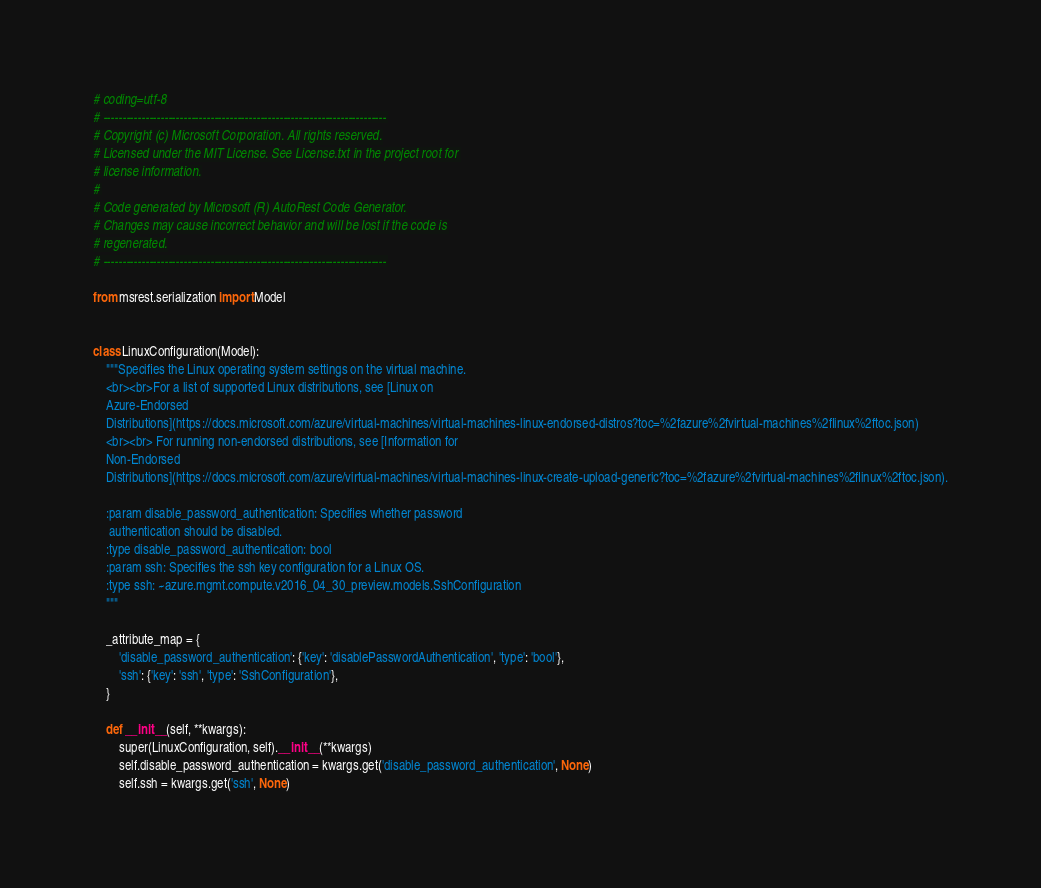<code> <loc_0><loc_0><loc_500><loc_500><_Python_># coding=utf-8
# --------------------------------------------------------------------------
# Copyright (c) Microsoft Corporation. All rights reserved.
# Licensed under the MIT License. See License.txt in the project root for
# license information.
#
# Code generated by Microsoft (R) AutoRest Code Generator.
# Changes may cause incorrect behavior and will be lost if the code is
# regenerated.
# --------------------------------------------------------------------------

from msrest.serialization import Model


class LinuxConfiguration(Model):
    """Specifies the Linux operating system settings on the virtual machine.
    <br><br>For a list of supported Linux distributions, see [Linux on
    Azure-Endorsed
    Distributions](https://docs.microsoft.com/azure/virtual-machines/virtual-machines-linux-endorsed-distros?toc=%2fazure%2fvirtual-machines%2flinux%2ftoc.json)
    <br><br> For running non-endorsed distributions, see [Information for
    Non-Endorsed
    Distributions](https://docs.microsoft.com/azure/virtual-machines/virtual-machines-linux-create-upload-generic?toc=%2fazure%2fvirtual-machines%2flinux%2ftoc.json).

    :param disable_password_authentication: Specifies whether password
     authentication should be disabled.
    :type disable_password_authentication: bool
    :param ssh: Specifies the ssh key configuration for a Linux OS.
    :type ssh: ~azure.mgmt.compute.v2016_04_30_preview.models.SshConfiguration
    """

    _attribute_map = {
        'disable_password_authentication': {'key': 'disablePasswordAuthentication', 'type': 'bool'},
        'ssh': {'key': 'ssh', 'type': 'SshConfiguration'},
    }

    def __init__(self, **kwargs):
        super(LinuxConfiguration, self).__init__(**kwargs)
        self.disable_password_authentication = kwargs.get('disable_password_authentication', None)
        self.ssh = kwargs.get('ssh', None)
</code> 